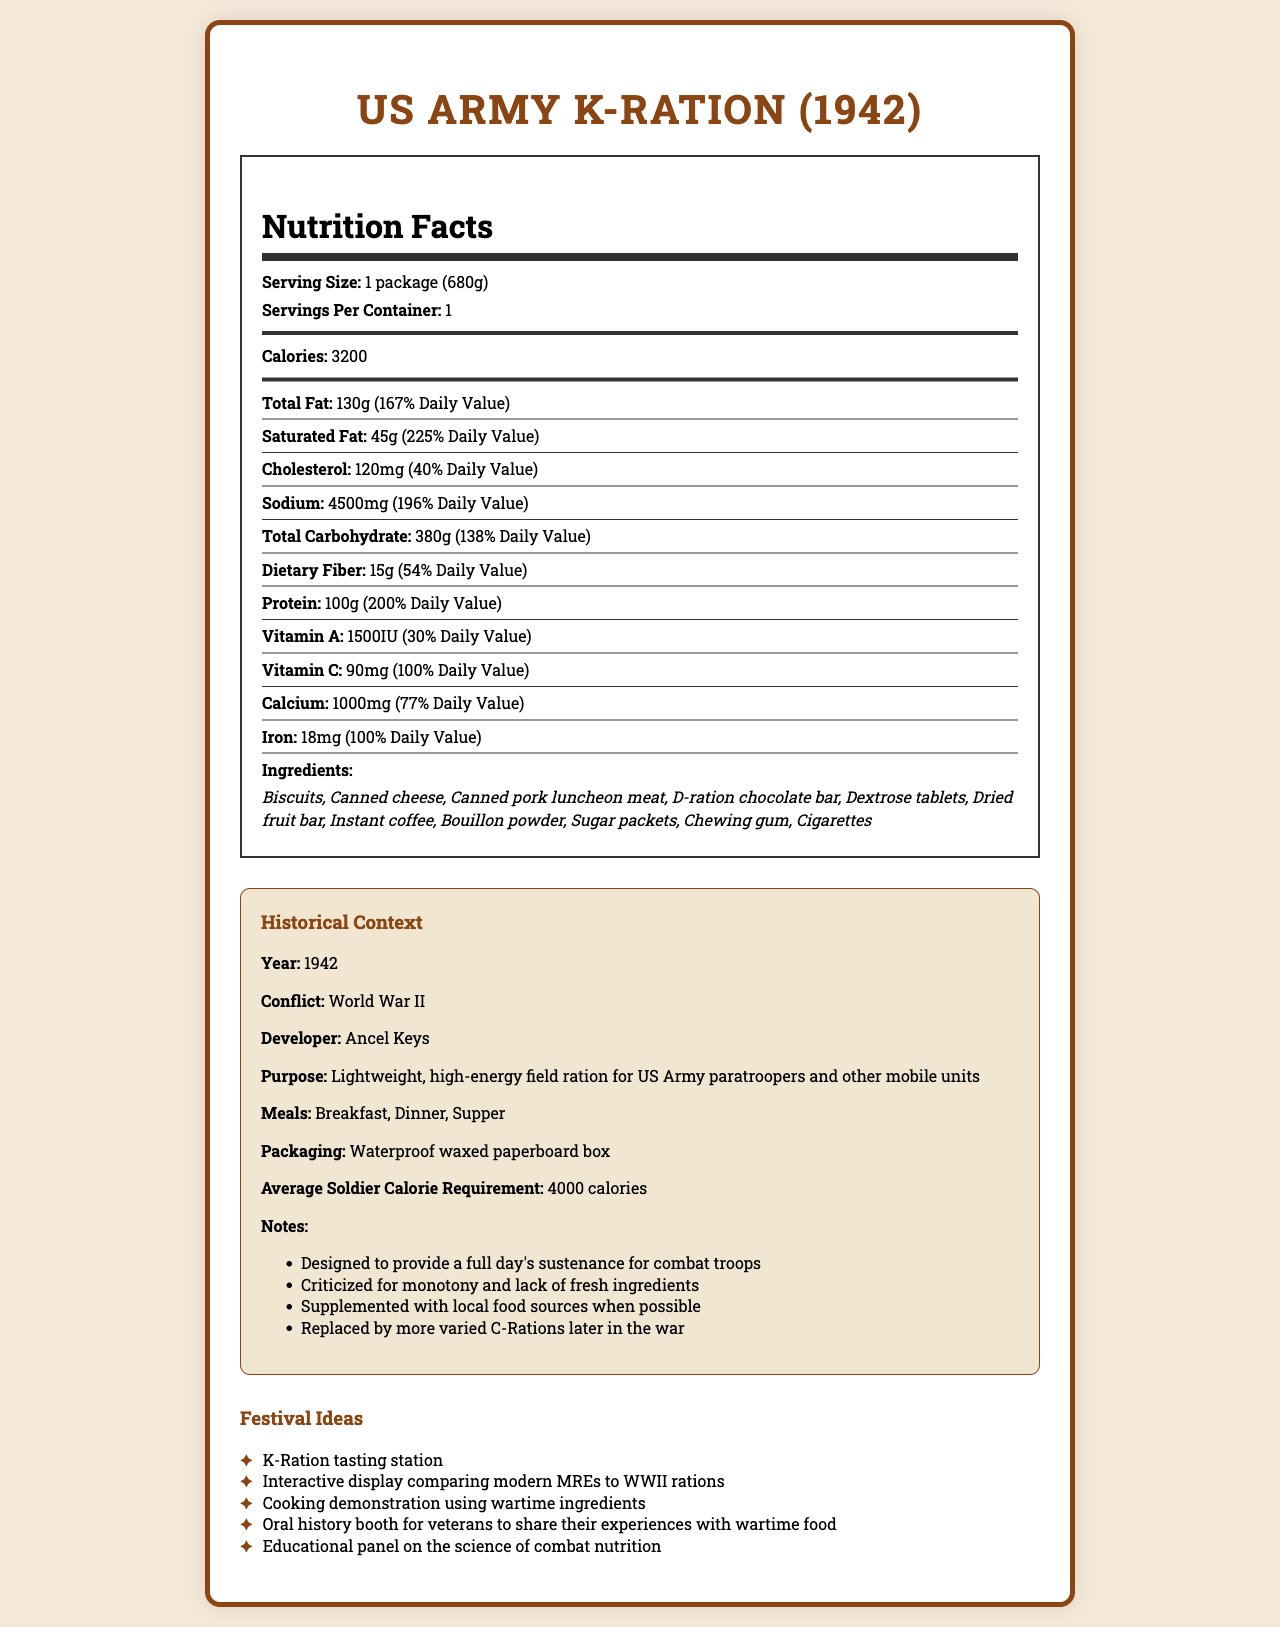what is the serving size of the US Army K-Ration (1942)? The serving size is listed as "1 package (680g)" in the nutrition facts section of the document.
Answer: 1 package (680g) how many calories does one serving of the US Army K-Ration (1942) provide? The document specifies that one serving provides "3200" calories.
Answer: 3200 calories what percentage of the daily value of saturated fat does the US Army K-Ration (1942) contain? The nutrition facts indicate that the K-Ration contains 45g of saturated fat, which corresponds to 225% of the daily value.
Answer: 225% how much sodium does the US Army K-Ration (1942) contain per serving? The nutrition facts list the sodium content as "4500 mg" per serving.
Answer: 4500 mg name three ingredients included in the US Army K-Ration (1942). Biscuits, Canned cheese, and D-ration chocolate bar are all listed in the ingredients section.
Answer: Biscuits, Canned cheese, D-ration chocolate bar what was the purpose of developing the US Army K-Ration (1942)? A. To replace all existing rations B. To provide sustenance for civilian populations C. To provide a lightweight, high-energy field ration for soldiers The purpose of the K-Ration was to serve as a lightweight, high-energy field ration for US Army paratroopers and other mobile units, as stated in the historical context section.
Answer: C which nutrient has the highest daily value percentage in the K-Ration? A. Protein B. Total Carbohydrate C. Sodium D. Vitamin C The highest daily value percentage listed is for Vitamin C at 100%, whereas other nutrients have lower percentages.
Answer: D. Vitamin C is the US Army K-Ration (1942) intended to cover a soldier's full day's sustenance? The historical context notes indicate that the K-Ration was designed to provide a full day's sustenance for combat troops.
Answer: Yes give a brief summary of the US Army K-Ration (1942) document. The document provides detailed nutritional facts and historical context for the US Army K-Ration developed in 1942. It includes information on the serving size, caloric content, nutrients, ingredients, historical notes, and possible festival ideas to celebrate its historical significance.
Answer: The document provides nutritional information for the US Army K-Ration (1942), indicating its purpose as a lightweight, high-energy field ration for mobile military units during WWII. It contains nutritional content, ingredients, historical development, and festival ideas related to the K-Ration. how did soldiers typically supplement the K-Ration in wartime environments? The historical notes mention that the K-Ration was supplemented with local food sources whenever possible.
Answer: Local food sources what is the average soldier's daily calorie requirement during the period of the K-Ration's use? The historical context section states that the average soldier's calorie requirement was 4000 calories per day.
Answer: 4000 calories how much dietary fiber does the K-Ration contain? The nutritional content lists the K-Ration as containing 15g of dietary fiber per serving.
Answer: 15g who was the developer of the US Army K-Ration (1942)? The historical context attributes the development of the K-Ration to Ancel Keys.
Answer: Ancel Keys does the US Army K-Ration (1942) contain any trans fat? The nutrition facts specify that the K-Ration contains 0g of trans fat.
Answer: No what was one criticism of the K-Ration during wartime use? The historical context notes that the K-Ration was criticized for its monotony and lack of fresh ingredients.
Answer: Monotony and lack of fresh ingredients what was the packaging material used for the K-Ration? The historical context specifies that the K-Ration was packaged in a waterproof waxed paperboard box.
Answer: Waterproof waxed paperboard box how many types of meals did the K-Ration include? A. One B. Two C. Three D. Four The historical context lists Breakfast, Dinner, and Supper as the three types of meals included in the K-Ration.
Answer: C. Three does the document provide exact recipes for any of the K-Ration components? The document lists ingredients and nutritional information but does not provide any exact recipes for the components of the K-Ration.
Answer: Not enough information 